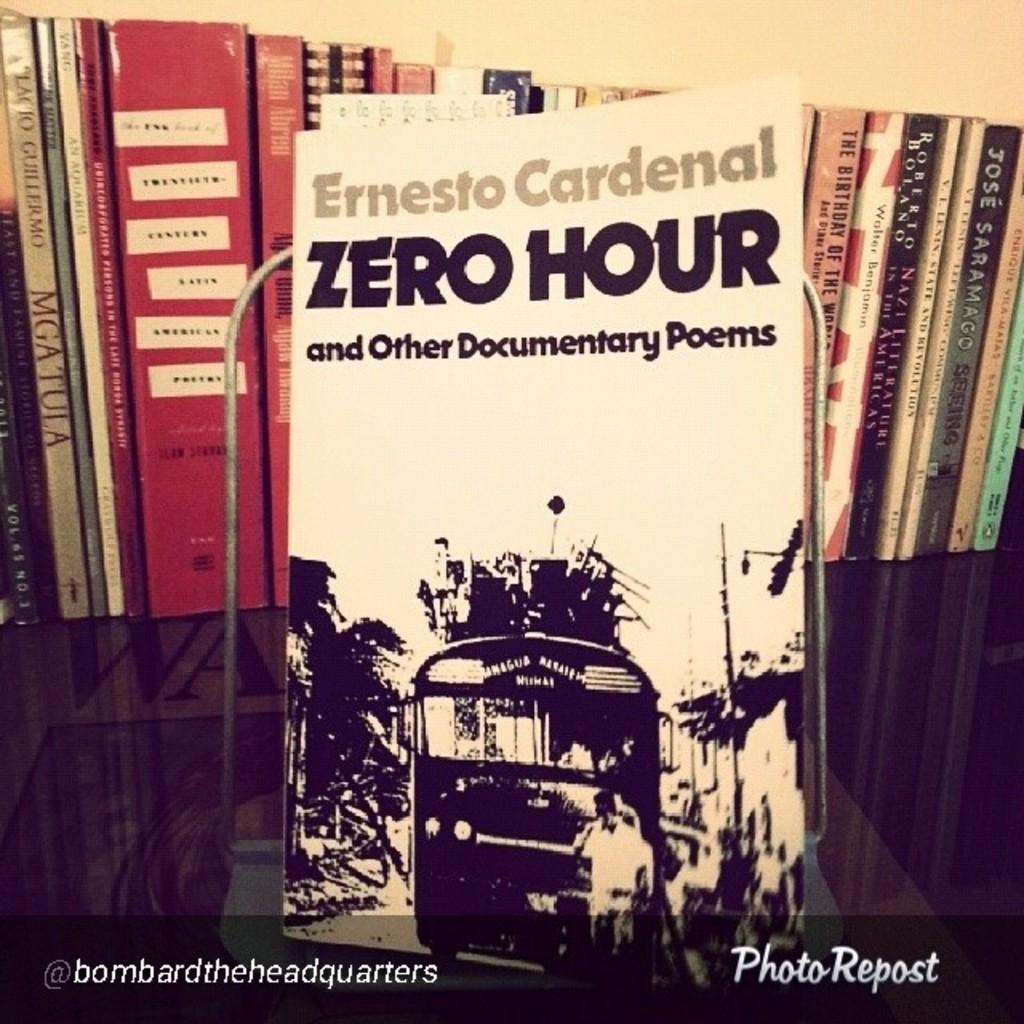What is the title of the book?
Provide a succinct answer. Zero hour. Who is the author?
Offer a very short reply. Ernesto cardenal. 